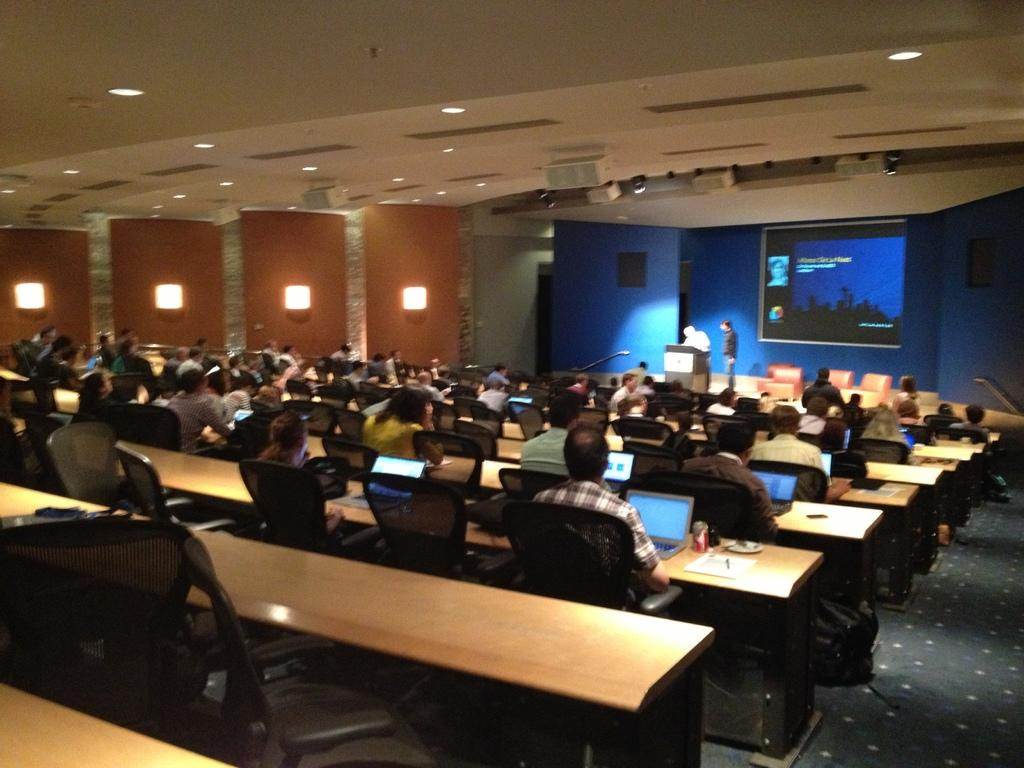What are the people in the image doing? The people in the image are sitting on chairs. What objects are on the tables in the image? There are laptops on tables in the image. What can be seen on the screen in the image? The screen is visible in the image, but its content is not specified. What are the two men standing next to in the image? The two men are standing next to a podium in the image. What type of map is visible on the screen in the image? There is no map visible on the screen in the image. What color are the jeans worn by the people sitting on chairs in the image? The provided facts do not mention the color of any jeans worn by the people in the image. 